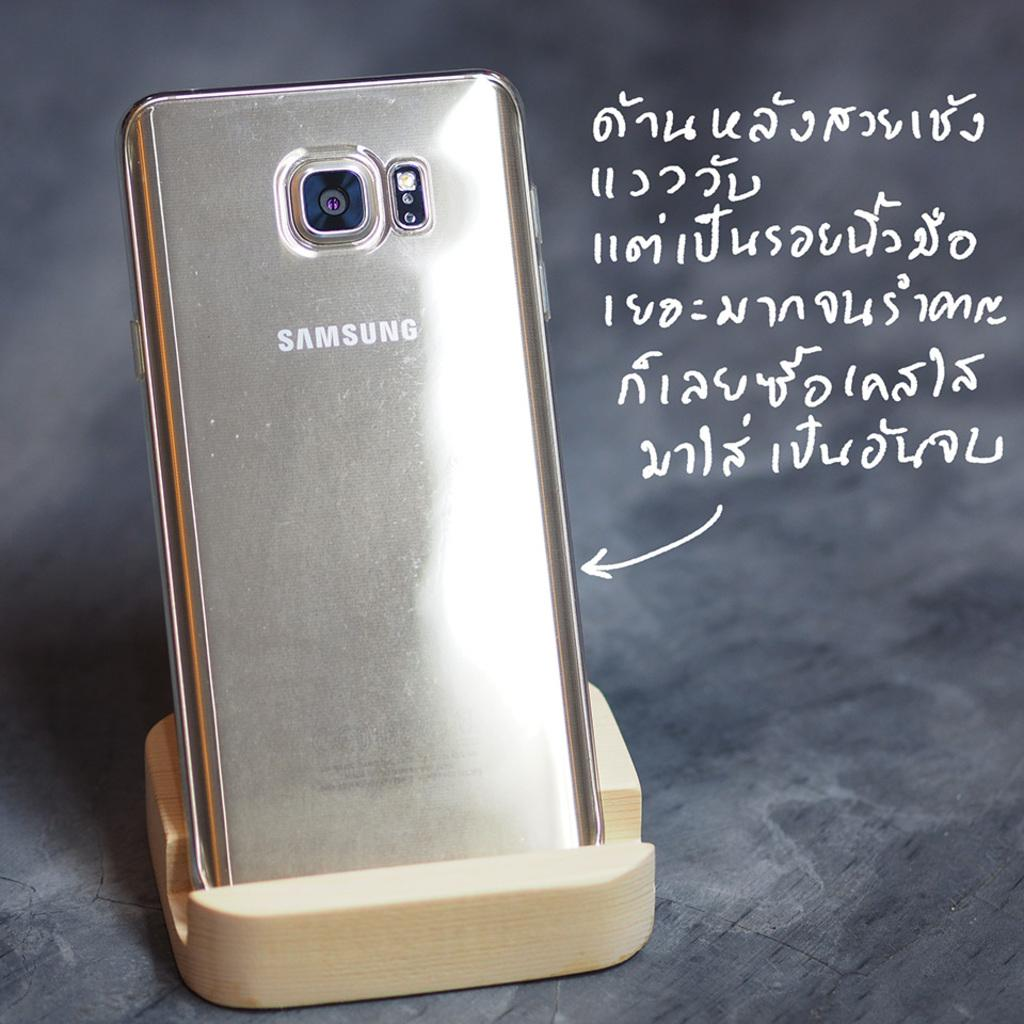Provide a one-sentence caption for the provided image. A samsung phone sitting in a holder with a foreign language written to the side.. 